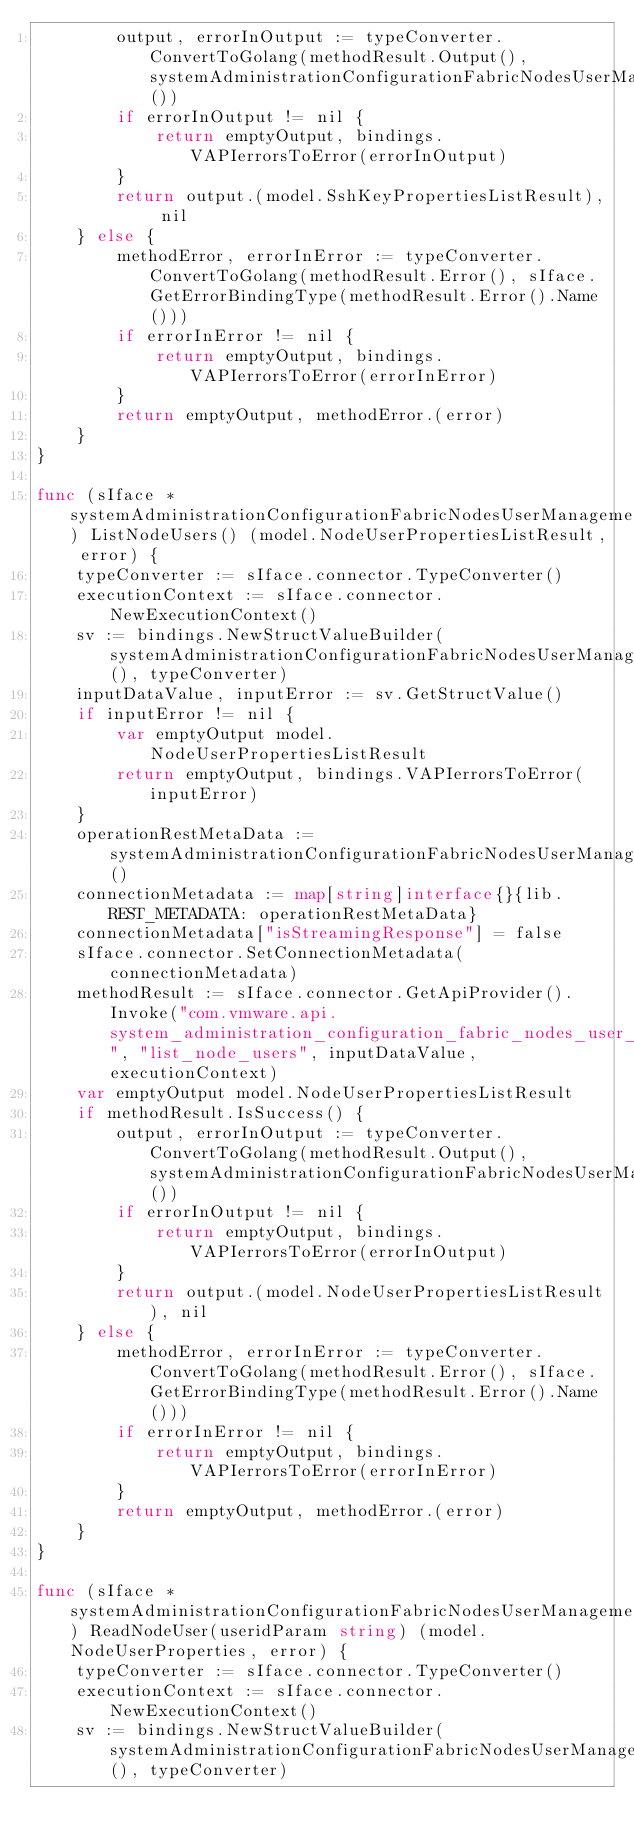<code> <loc_0><loc_0><loc_500><loc_500><_Go_>		output, errorInOutput := typeConverter.ConvertToGolang(methodResult.Output(), systemAdministrationConfigurationFabricNodesUserManagementUsersListNodeUserSshKeysOutputType())
		if errorInOutput != nil {
			return emptyOutput, bindings.VAPIerrorsToError(errorInOutput)
		}
		return output.(model.SshKeyPropertiesListResult), nil
	} else {
		methodError, errorInError := typeConverter.ConvertToGolang(methodResult.Error(), sIface.GetErrorBindingType(methodResult.Error().Name()))
		if errorInError != nil {
			return emptyOutput, bindings.VAPIerrorsToError(errorInError)
		}
		return emptyOutput, methodError.(error)
	}
}

func (sIface *systemAdministrationConfigurationFabricNodesUserManagementUsersClient) ListNodeUsers() (model.NodeUserPropertiesListResult, error) {
	typeConverter := sIface.connector.TypeConverter()
	executionContext := sIface.connector.NewExecutionContext()
	sv := bindings.NewStructValueBuilder(systemAdministrationConfigurationFabricNodesUserManagementUsersListNodeUsersInputType(), typeConverter)
	inputDataValue, inputError := sv.GetStructValue()
	if inputError != nil {
		var emptyOutput model.NodeUserPropertiesListResult
		return emptyOutput, bindings.VAPIerrorsToError(inputError)
	}
	operationRestMetaData := systemAdministrationConfigurationFabricNodesUserManagementUsersListNodeUsersRestMetadata()
	connectionMetadata := map[string]interface{}{lib.REST_METADATA: operationRestMetaData}
	connectionMetadata["isStreamingResponse"] = false
	sIface.connector.SetConnectionMetadata(connectionMetadata)
	methodResult := sIface.connector.GetApiProvider().Invoke("com.vmware.api.system_administration_configuration_fabric_nodes_user_management_users", "list_node_users", inputDataValue, executionContext)
	var emptyOutput model.NodeUserPropertiesListResult
	if methodResult.IsSuccess() {
		output, errorInOutput := typeConverter.ConvertToGolang(methodResult.Output(), systemAdministrationConfigurationFabricNodesUserManagementUsersListNodeUsersOutputType())
		if errorInOutput != nil {
			return emptyOutput, bindings.VAPIerrorsToError(errorInOutput)
		}
		return output.(model.NodeUserPropertiesListResult), nil
	} else {
		methodError, errorInError := typeConverter.ConvertToGolang(methodResult.Error(), sIface.GetErrorBindingType(methodResult.Error().Name()))
		if errorInError != nil {
			return emptyOutput, bindings.VAPIerrorsToError(errorInError)
		}
		return emptyOutput, methodError.(error)
	}
}

func (sIface *systemAdministrationConfigurationFabricNodesUserManagementUsersClient) ReadNodeUser(useridParam string) (model.NodeUserProperties, error) {
	typeConverter := sIface.connector.TypeConverter()
	executionContext := sIface.connector.NewExecutionContext()
	sv := bindings.NewStructValueBuilder(systemAdministrationConfigurationFabricNodesUserManagementUsersReadNodeUserInputType(), typeConverter)</code> 